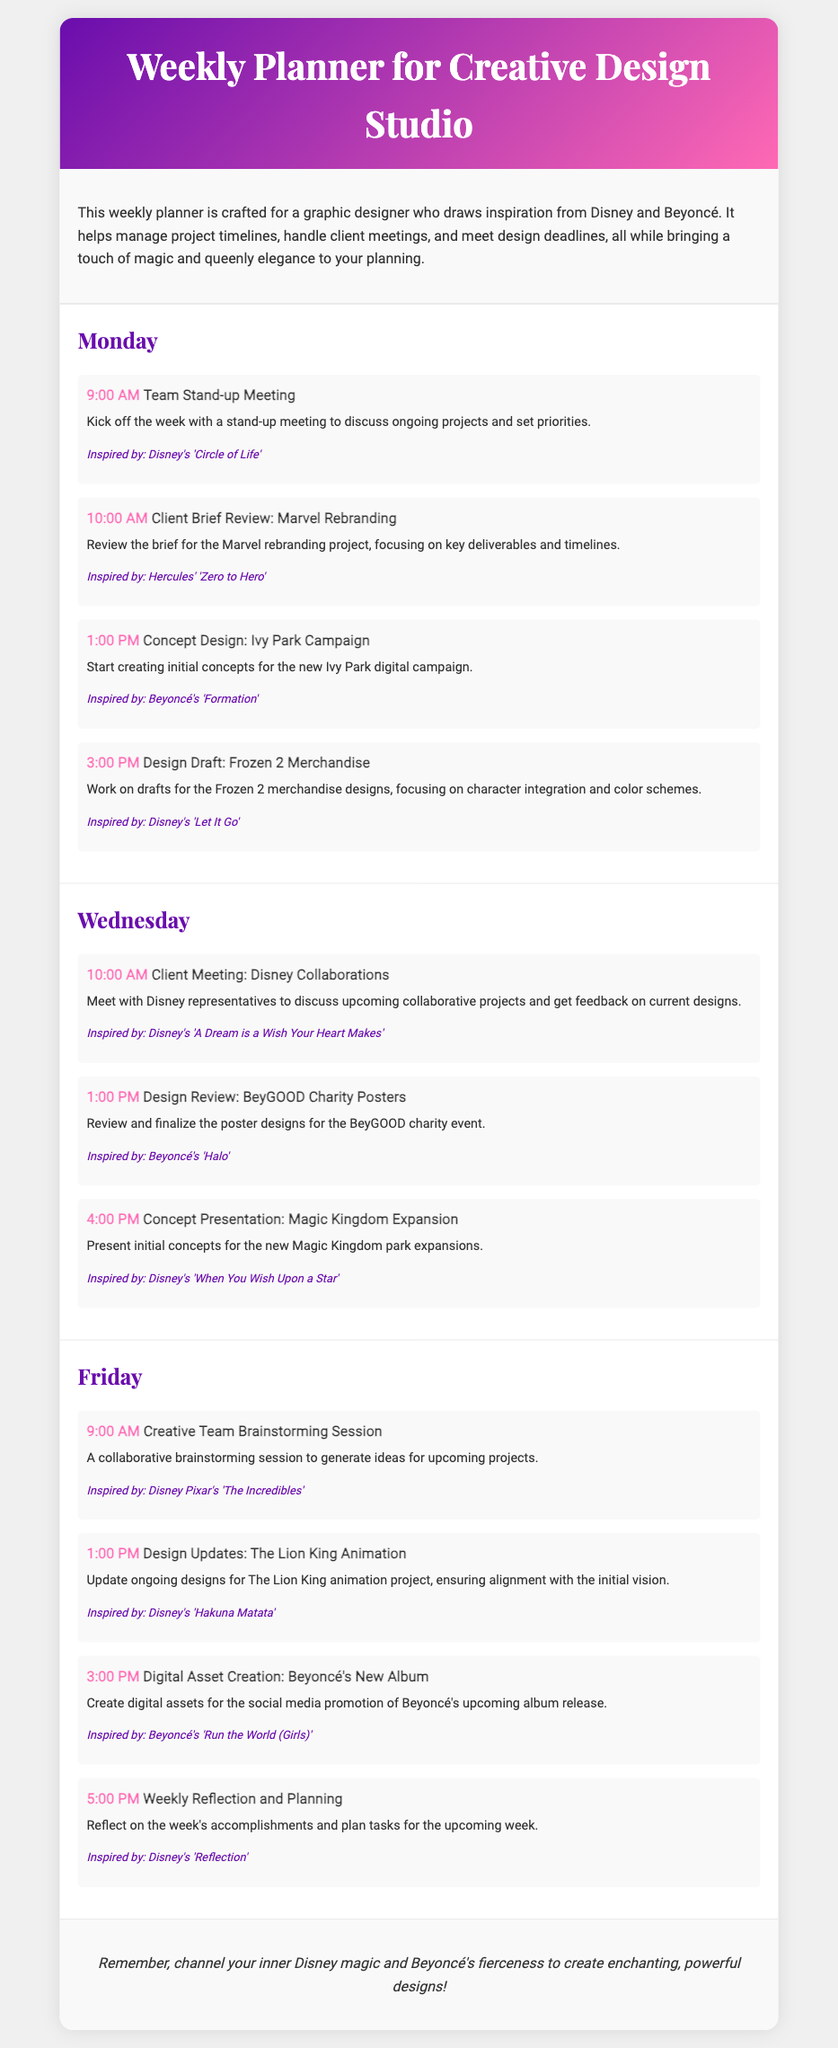What is the title of the document? The title is prominently displayed in the header section of the document.
Answer: Weekly Planner for Creative Design Studio What day is the client meeting with Disney representatives scheduled? The day is mentioned under the specific activities planned for that day.
Answer: Wednesday What time is the team stand-up meeting? The time is explicitly stated within the activity section of Monday.
Answer: 9:00 AM What project is being reviewed during the client brief on Monday? The project name is included in the description of the client's brief review activity.
Answer: Marvel Rebranding Which Beyoncé song inspired the concept design for the Ivy Park campaign? The song title is mentioned in the activity description for that day.
Answer: Formation How many activities are scheduled for Friday? The number of activities can be counted directly from the Friday section of the document.
Answer: 4 What is the purpose of the weekly reflection and planning session? The purpose is described in the activity description for that time slot.
Answer: Reflect on the week's accomplishments and plan tasks Which Disney movie inspired the design draft for merchandise on Monday? The movie is mentioned in the activity description under Monday's activities.
Answer: Frozen 2 What design project will have a creative team brainstorming session? The project is included in the description of the activity scheduled for Friday.
Answer: Upcoming projects 